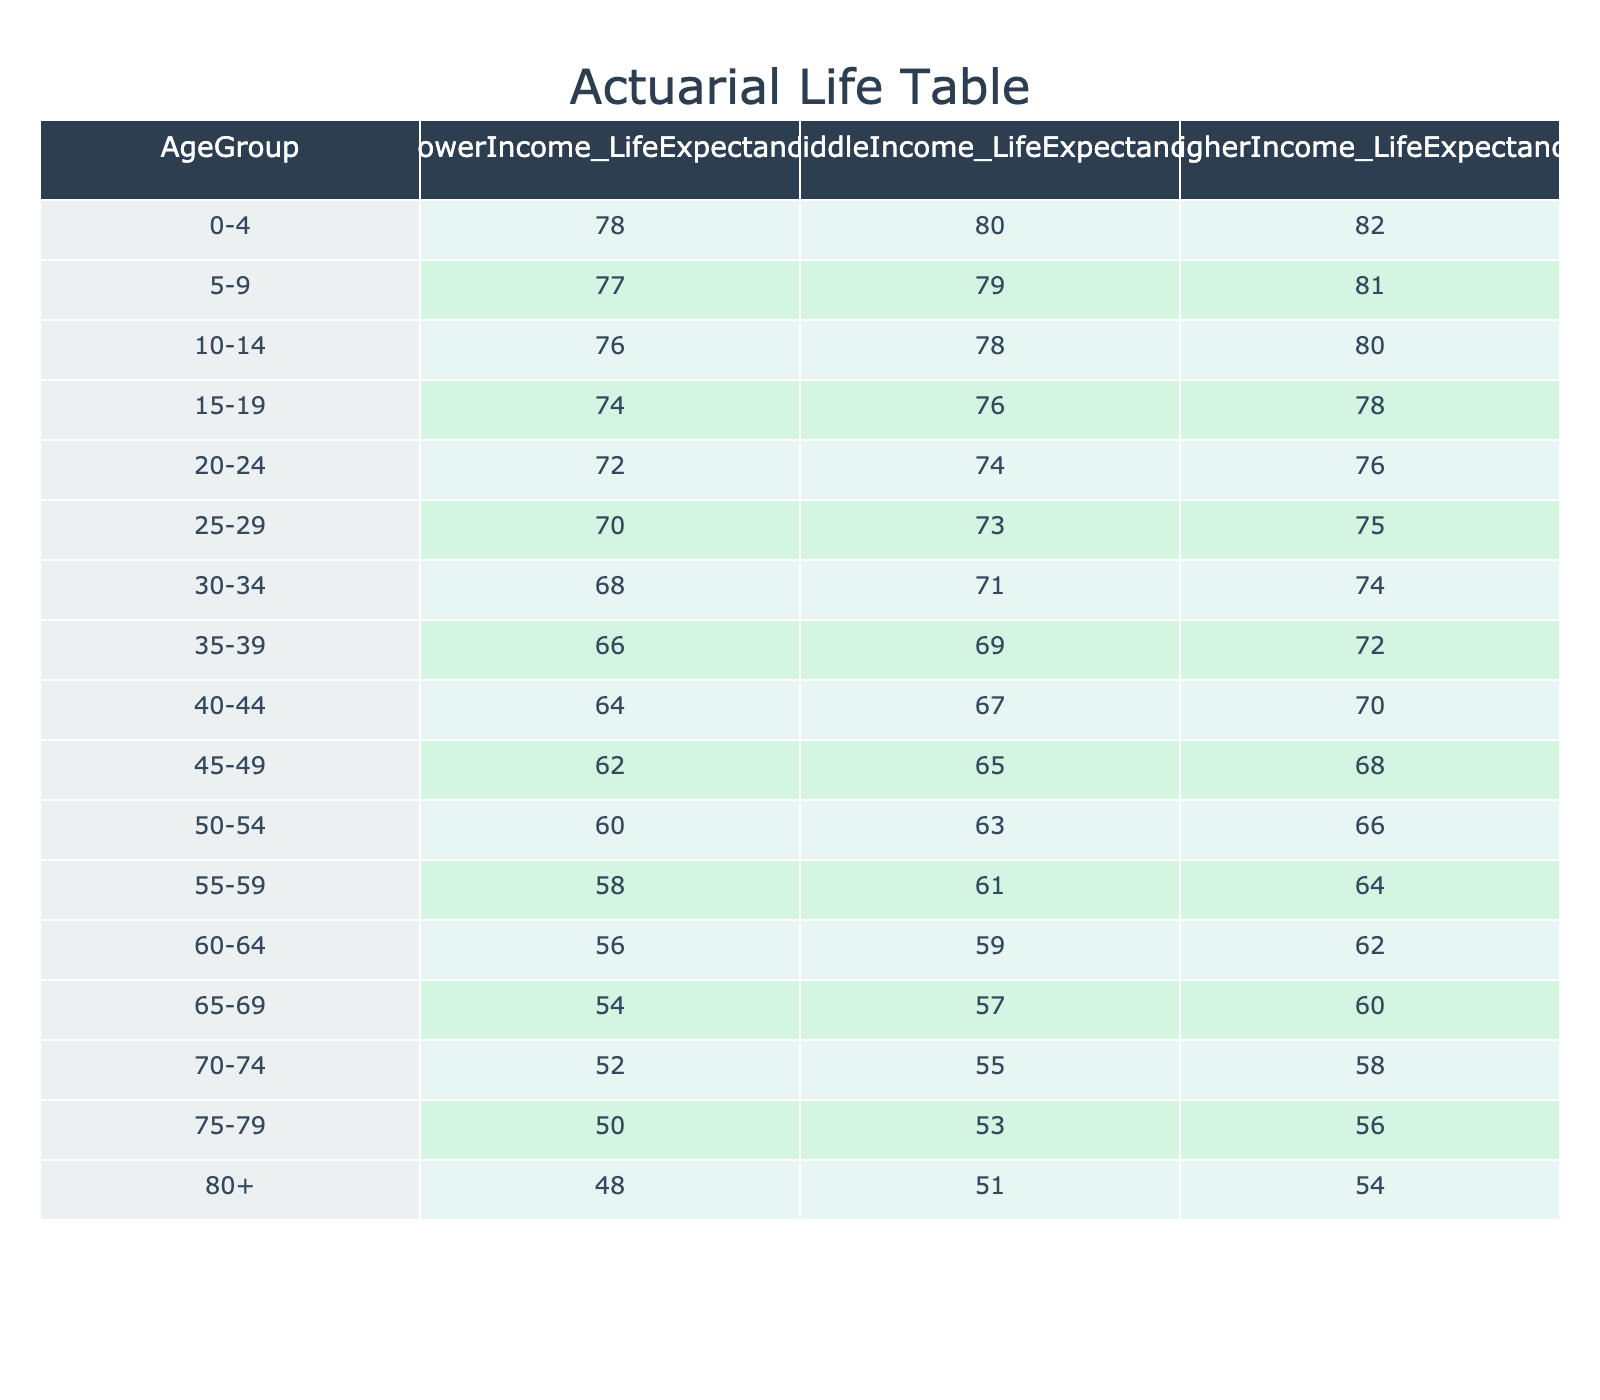What is the life expectancy for individuals aged 25-29 with higher income? The table shows that for the age group 25-29, the life expectancy for higher income individuals is listed as 75 years.
Answer: 75 Which age group has the lowest life expectancy for lower income individuals? By examining the values for lower income individuals across all age groups, the lowest value is 48 years, which corresponds to the age group 80+.
Answer: 80+ What is the average life expectancy for middle income individuals across all age groups? To find the average, I sum up the life expectancies for middle income individuals (80 + 79 + 78 + 76 + 74 + 73 + 71 + 69 + 67 + 65 + 63 + 61 + 59 + 57 + 55 + 53 + 51) = 1153 years and divide by 17 age groups, giving an average of 1153 / 17 = approx 67.24 years.
Answer: Approximately 67.24 Is the life expectancy for higher income individuals aged 60-64 greater than or equal to that of lower income individuals in the same age group? For the age group 60-64, the life expectancy for higher income individuals is 62 years while that for lower income individuals is 56 years. Thus, yes, 62 is greater than 56.
Answer: Yes What is the difference in life expectancy between lower income and higher income individuals aged 50-54? For the age group 50-54, the life expectancy is 60 years for lower income and 66 years for higher income. The difference can be calculated as 66 - 60 = 6 years.
Answer: 6 What is the life expectancy trend among higher income individuals with increasing age? By reviewing the higher income life expectancy values listed in the table, from 0-4 to 80+, it's clear that the life expectancy decreases steadily from 82 years down to 54 years as age increases, indicating a decreasing trend.
Answer: Decreasing trend Are there any age groups where middle income life expectancy is equal to the higher income life expectancy? By comparing the values, we find that there are no age groups listed where the life expectancies for middle income and higher income individuals are the same; each age group has a distinct value.
Answer: No What is the sum of life expectancies for lower income individuals across ages 10-14 and 15-19? From the table, the life expectancy for lower income individuals aged 10-14 is 76 years and aged 15-19 is 74 years. The sum is 76 + 74 = 150 years.
Answer: 150 